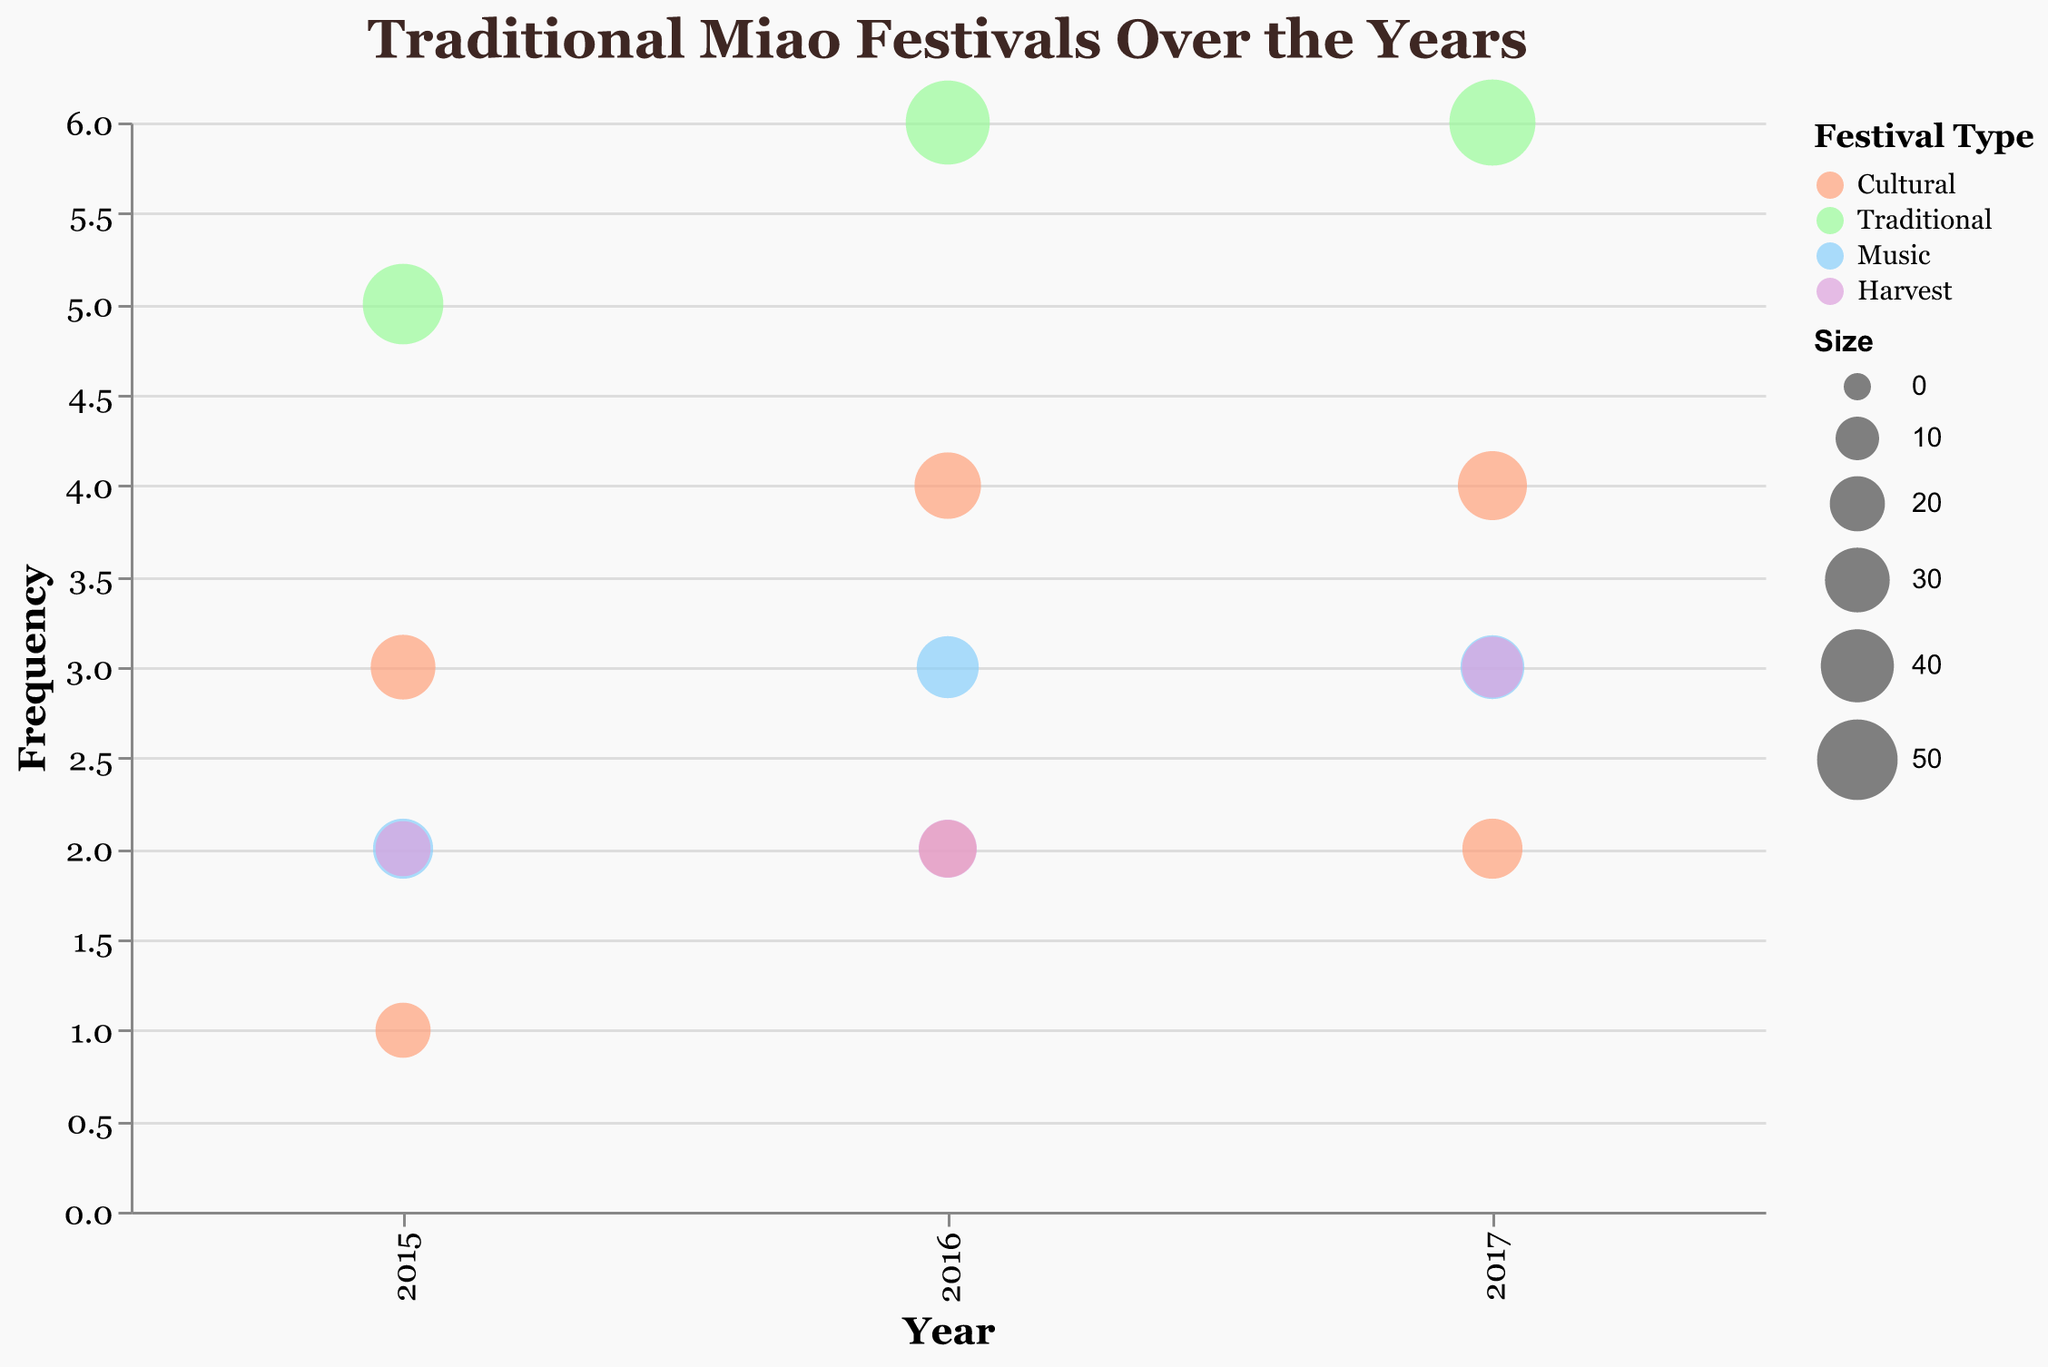What is the title of the chart? The title of the chart is written at the top, stating "Traditional Miao Festivals Over the Years".
Answer: Traditional Miao Festivals Over the Years How many festival types are represented in the chart and what are they? The legend shows four different colors representing the festival types: Cultural, Traditional, Music, and Harvest.
Answer: Four: Cultural, Traditional, Music, and Harvest Which festival has the highest frequency in 2017? By examining the y-axis and the bubbles for the year 2017, the New Year Festival has the highest frequency of 6.
Answer: New Year Festival What is the size of the bubble for the Dragon Boat Festival in 2016? Hovering over or referring to the tooltip for the Dragon Boat Festival in 2016 shows the size is 32.
Answer: 32 Which festival increased in frequency from 2015 to 2017 but remained the same in size from 2016 to 2017? The Flower Mountain Festival frequency increased from 2 (2015) to 3 (2017), and the size remained the same from 23 (2016) to 26 (2017).
Answer: Flower Mountain Festival What is the average frequency of the Sisters' Meal Festival over the three years? Summing the frequencies for 2015, 2016, and 2017 which are 1, 2, and 2 respectively, then dividing by 3: (1+2+2)/3 = 5/3 ≈ 1.67.
Answer: 1.67 How does the size of the New Year Festival in 2017 compare to the size of the Dragon Boat Festival in 2017? The New Year Festival size is 58, while the Dragon Boat Festival size is 35 in 2017. 58 is greater than 35.
Answer: The New Year Festival in 2017 is larger What color represents Music festivals, and which years show these festivals? The blue color on the legend represents Music festivals, and these festivals are shown in the years 2015, 2016, and 2017.
Answer: Blue, 2015, 2016, 2017 What is the trend in frequency for the Lusheng Festival from 2015 to 2017? The frequency for the Lusheng Festival increases from 2 (2015) to 3 (2016) and stays at 3 (2017).
Answer: Increasing, then constant Which year shows the highest variety of festival types, and what are they? Each year can be reviewed to see the variety in festival types: 2015, 2016, and 2017 all show four types: Cultural, Traditional, Music, and Harvest.
Answer: 2015, 2016, and 2017 all have the same variety 